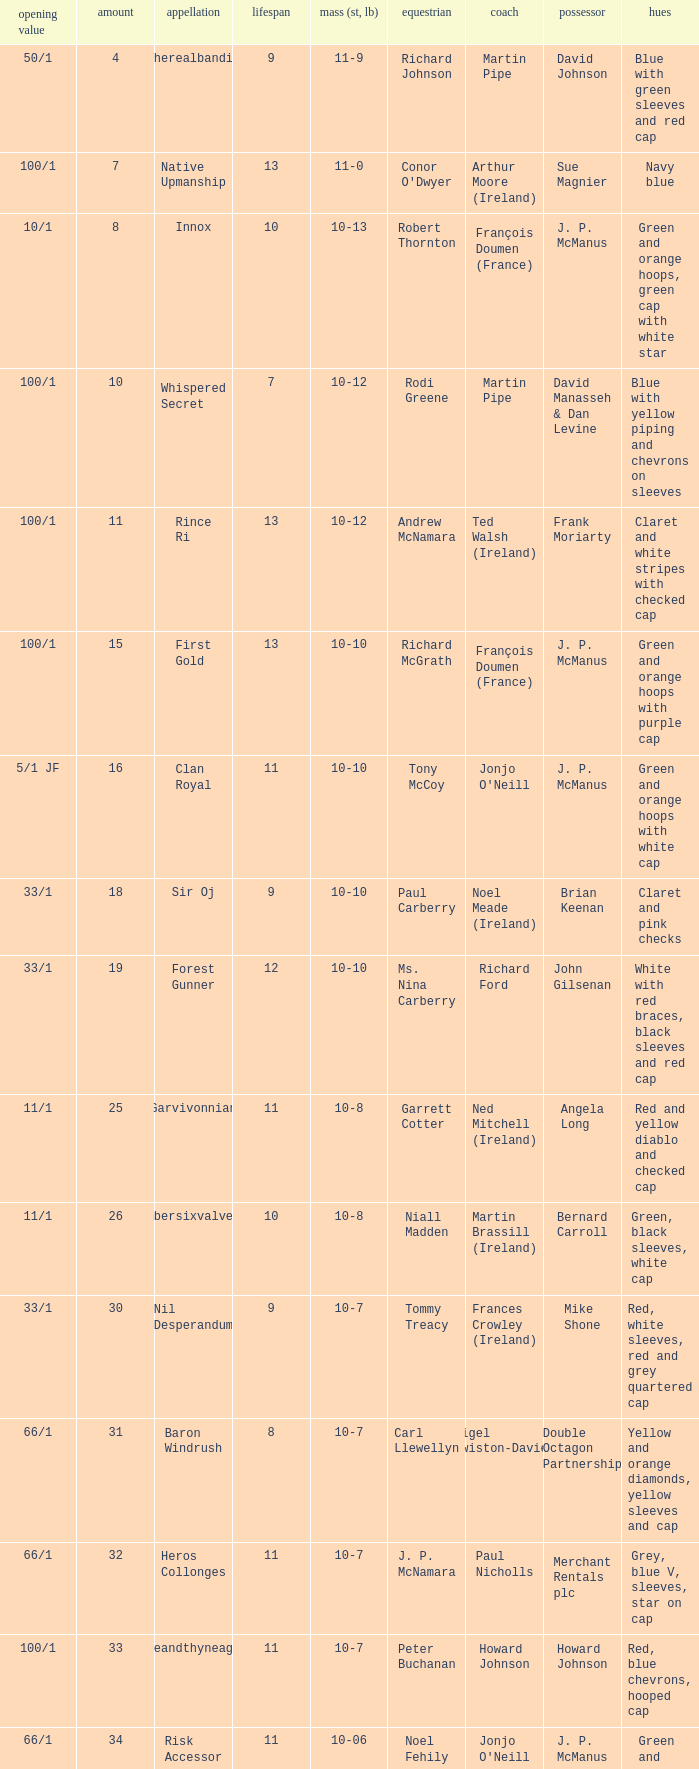How many age entries had a weight of 10-7 and an owner of Double Octagon Partnership? 1.0. 